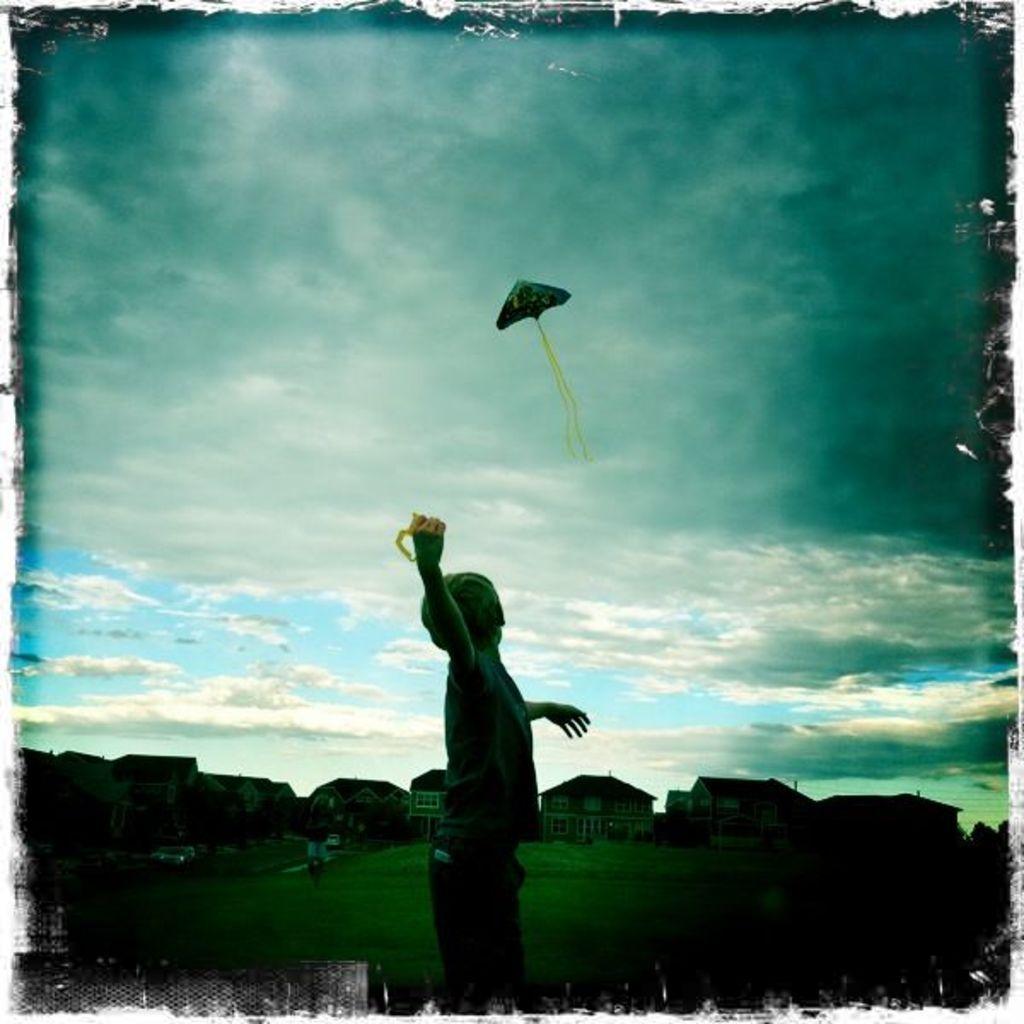How would you summarize this image in a sentence or two? In this picture we can see a boy standing, buildings with windows, grass and in the background we can see a kite flying in the sky with clouds. 